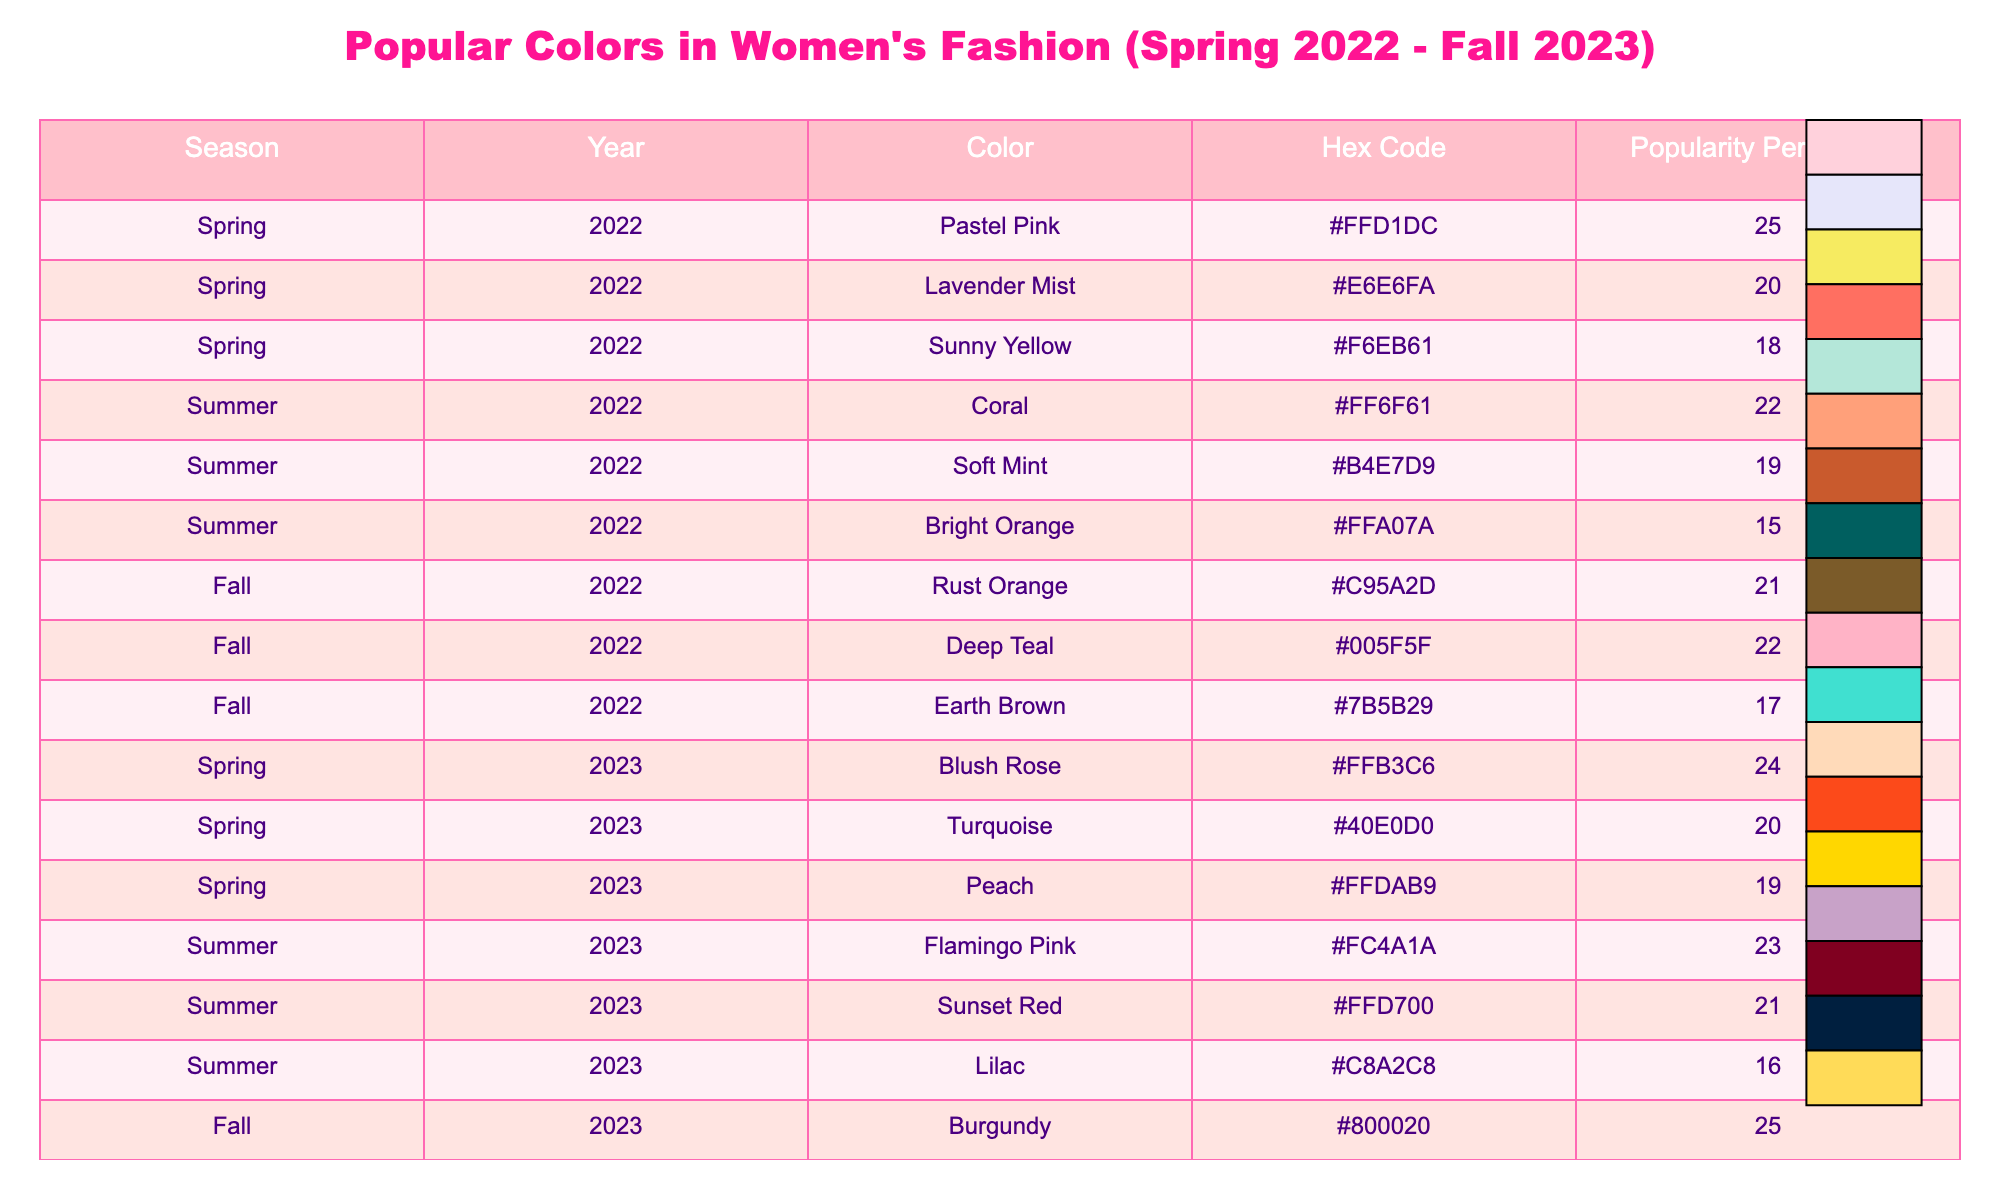What color had the highest popularity in Spring 2022? In Spring 2022, the color with the highest popularity percentage is Pastel Pink at 25%.
Answer: Pastel Pink What is the popularity percentage of Mustard Yellow in Fall 2023? The popularity percentage of Mustard Yellow in Fall 2023 is 18%.
Answer: 18% Which season had the least popular shade in Summer 2023? In Summer 2023, Lilac was the least popular color with a popularity percentage of 16%.
Answer: Lilac What is the average popularity of the colors in Spring 2023? The popularity percentages in Spring 2023 are 24%, 20%, and 19%. Summing these gives 63%, and dividing by 3, the average popularity is 21%.
Answer: 21% Did Deep Teal have a higher popularity percentage than Earth Brown in Fall 2022? Yes, Deep Teal's popularity percentage is 22%, while Earth Brown's is 17%, thus Deep Teal is more popular.
Answer: Yes What’s the difference in popularity between Burgandy in Fall 2023 and Pastel Pink in Spring 2022? Burgandy has a popularity of 25% in Fall 2023 while Pastel Pink is 25% in Spring 2022. The difference is 25% - 25% = 0%.
Answer: 0% What was the most popular color across all seasons? Examining the data, Pastel Pink, Blush Rose, and Burgandy all peak at 25%, making them the most popular colors.
Answer: Pastel Pink, Blush Rose, and Burgandy How many colors had a popularity percentage of 20% across the table? The colors with a 20% popularity percentage in the table are Lavender Mist (Spring 2022), Turquoise (Spring 2023), and Navy Blue (Fall 2023), totaling 3 colors.
Answer: 3 Which season has the highest percentage of colors above 20%? In Summer 2023, two colors (Flamingo Pink at 23% and Sunset Red at 21%) exceed 20%. In contrast, all colors of Spring 2022 and Fall 2022 have simulated percentages reaching above 20%.
Answer: Summer 2023 